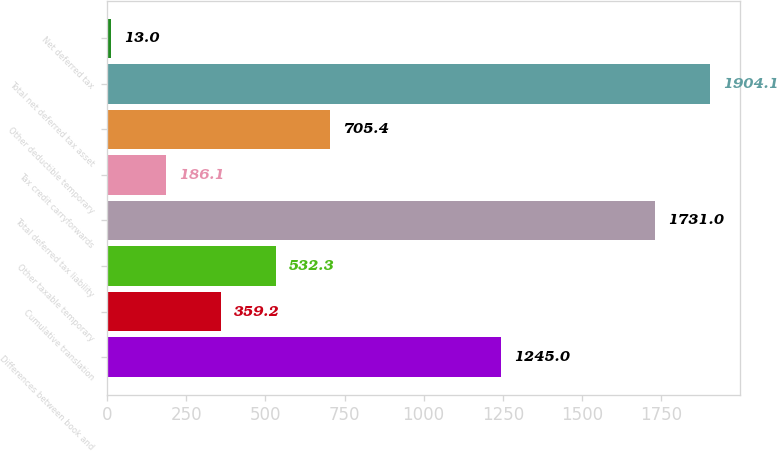Convert chart. <chart><loc_0><loc_0><loc_500><loc_500><bar_chart><fcel>Differences between book and<fcel>Cumulative translation<fcel>Other taxable temporary<fcel>Total deferred tax liability<fcel>Tax credit carryforwards<fcel>Other deductible temporary<fcel>Total net deferred tax asset<fcel>Net deferred tax<nl><fcel>1245<fcel>359.2<fcel>532.3<fcel>1731<fcel>186.1<fcel>705.4<fcel>1904.1<fcel>13<nl></chart> 